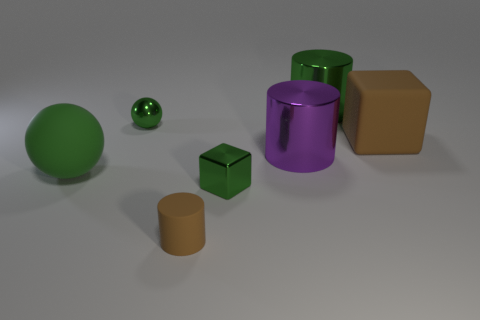Add 3 cylinders. How many objects exist? 10 Subtract all large metal cylinders. How many cylinders are left? 1 Subtract all balls. How many objects are left? 5 Subtract all cyan cylinders. Subtract all gray cubes. How many cylinders are left? 3 Subtract all green shiny balls. Subtract all big brown matte spheres. How many objects are left? 6 Add 3 big green matte balls. How many big green matte balls are left? 4 Add 6 green metallic cylinders. How many green metallic cylinders exist? 7 Subtract 2 green spheres. How many objects are left? 5 